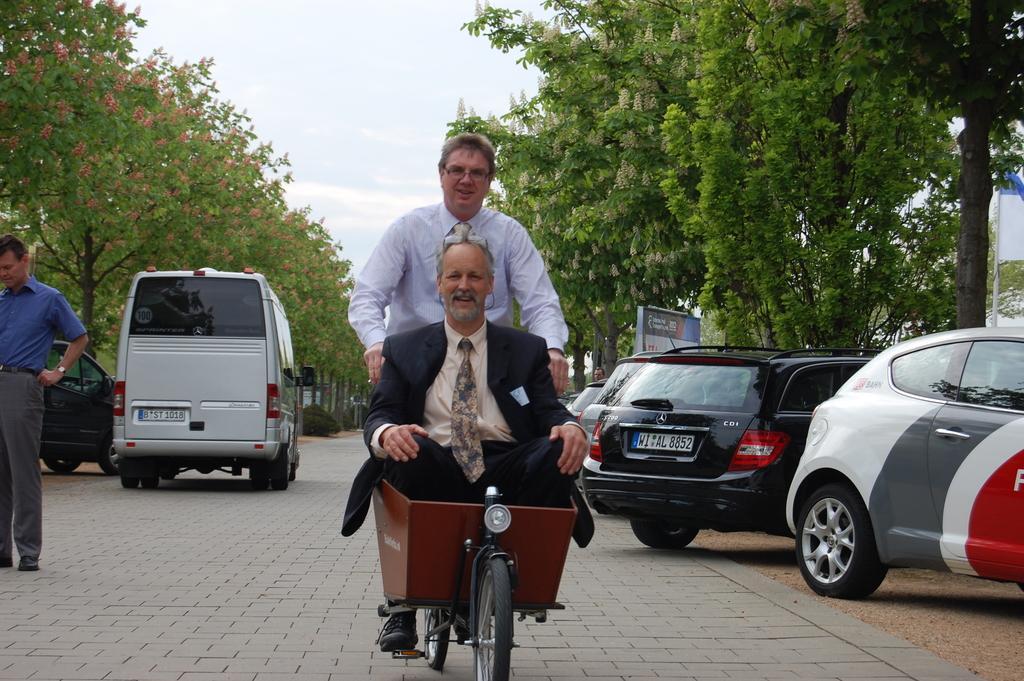How would you summarize this image in a sentence or two? These two persons are sitting on the vehicle and this person riding this vehicle,this person standing. We can see vehicles on the road. On the background we can see trees,sky. 